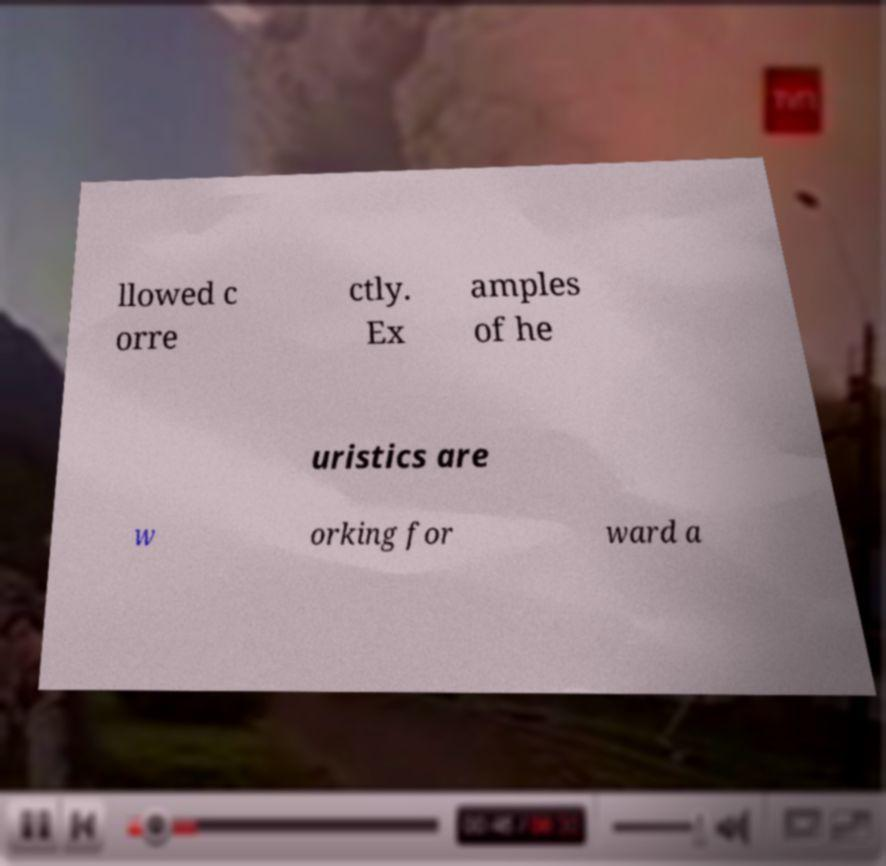Please read and relay the text visible in this image. What does it say? llowed c orre ctly. Ex amples of he uristics are w orking for ward a 